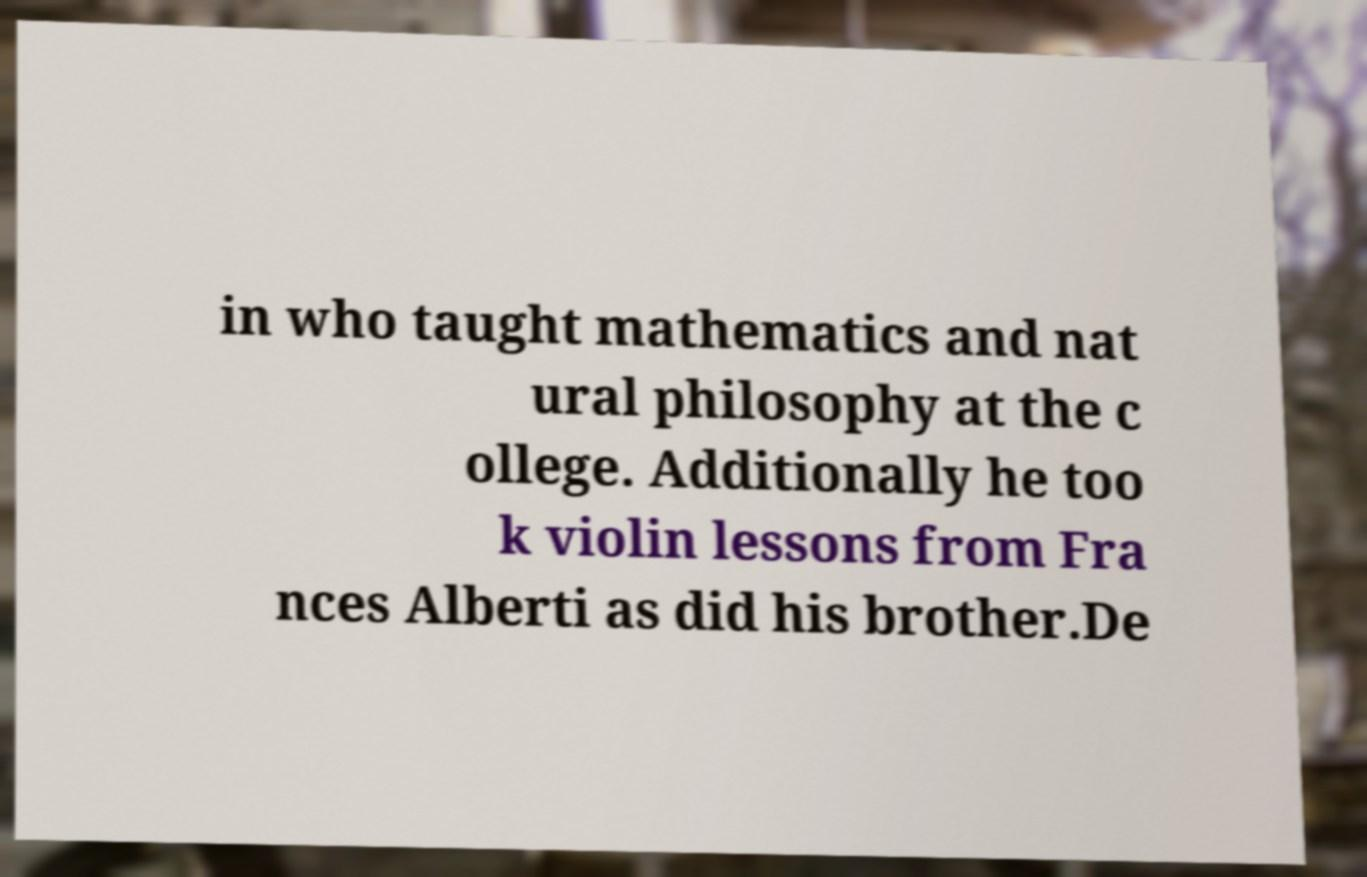There's text embedded in this image that I need extracted. Can you transcribe it verbatim? in who taught mathematics and nat ural philosophy at the c ollege. Additionally he too k violin lessons from Fra nces Alberti as did his brother.De 